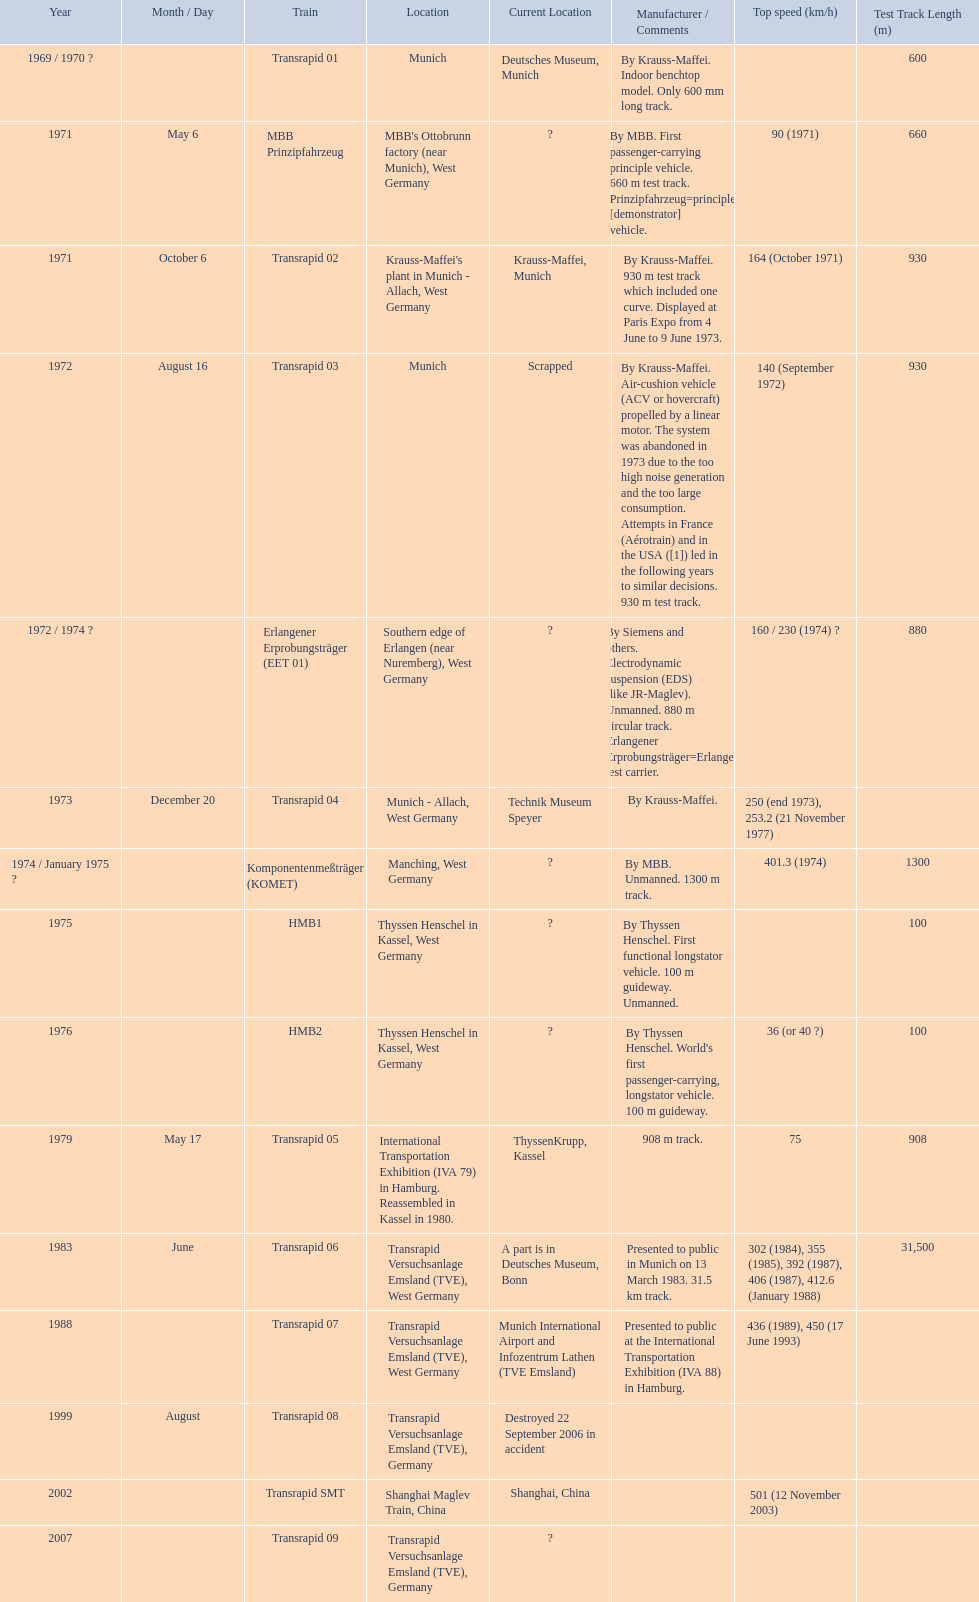What is the top speed reached by any trains shown here? 501 (12 November 2003). What train has reached a top speed of 501? Transrapid SMT. 